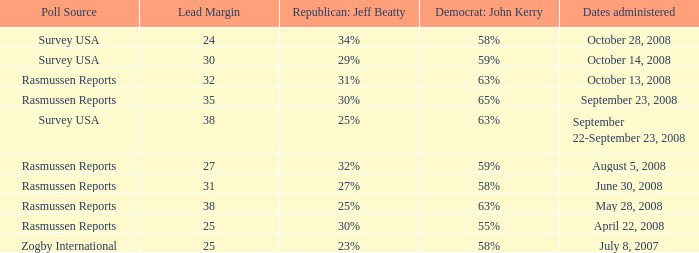What percent is the lead margin of 25 that Republican: Jeff Beatty has according to poll source Rasmussen Reports? 30%. 